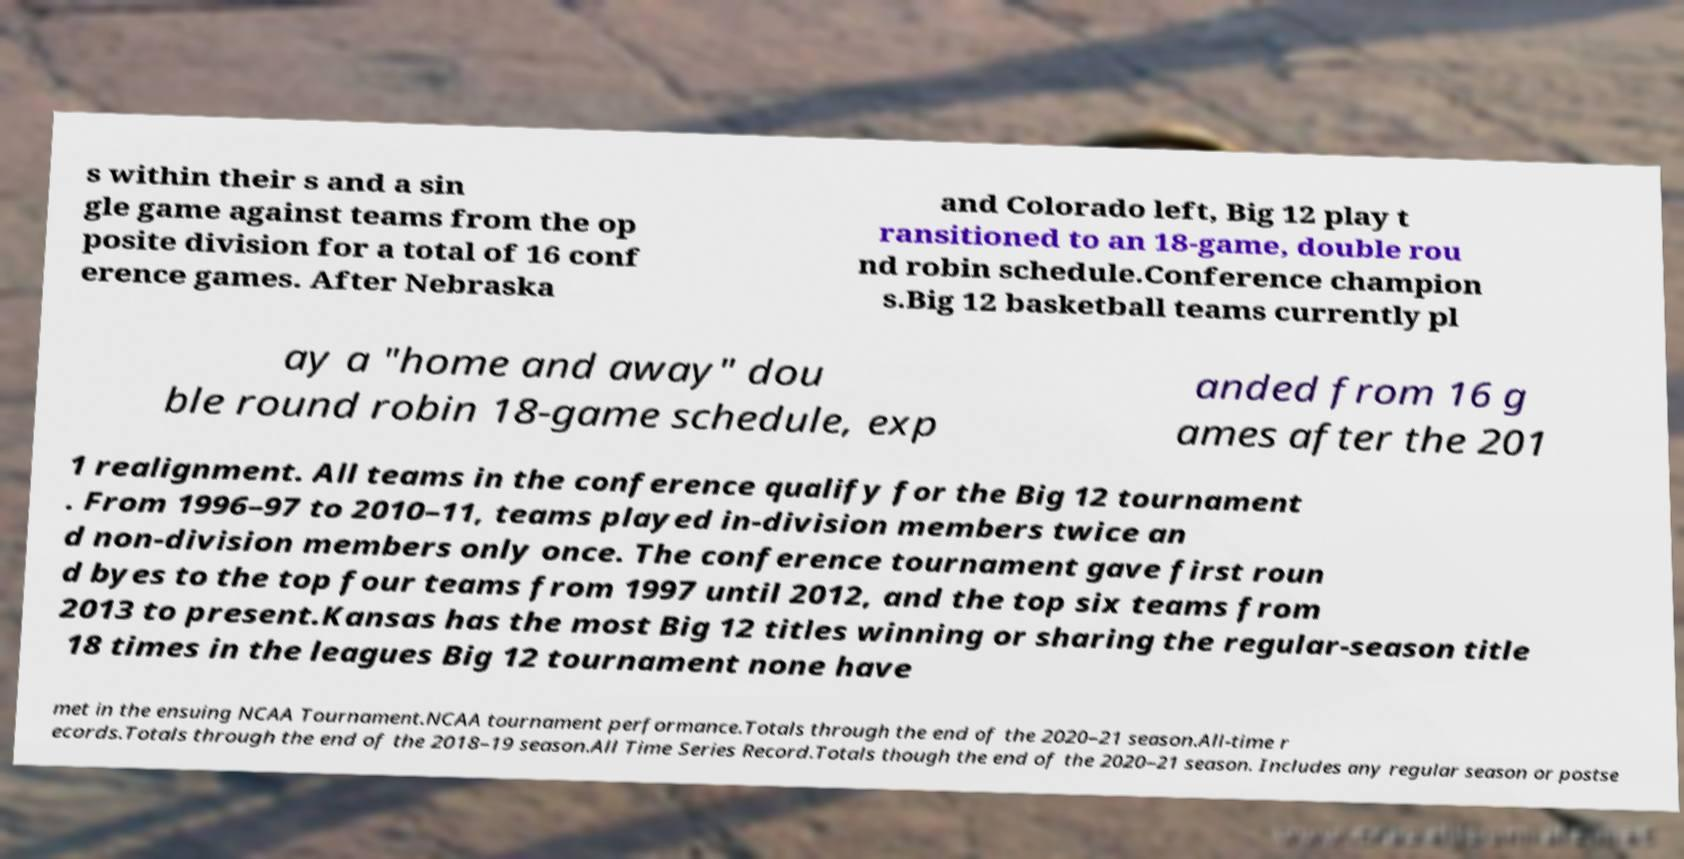What messages or text are displayed in this image? I need them in a readable, typed format. s within their s and a sin gle game against teams from the op posite division for a total of 16 conf erence games. After Nebraska and Colorado left, Big 12 play t ransitioned to an 18-game, double rou nd robin schedule.Conference champion s.Big 12 basketball teams currently pl ay a "home and away" dou ble round robin 18-game schedule, exp anded from 16 g ames after the 201 1 realignment. All teams in the conference qualify for the Big 12 tournament . From 1996–97 to 2010–11, teams played in-division members twice an d non-division members only once. The conference tournament gave first roun d byes to the top four teams from 1997 until 2012, and the top six teams from 2013 to present.Kansas has the most Big 12 titles winning or sharing the regular-season title 18 times in the leagues Big 12 tournament none have met in the ensuing NCAA Tournament.NCAA tournament performance.Totals through the end of the 2020–21 season.All-time r ecords.Totals through the end of the 2018–19 season.All Time Series Record.Totals though the end of the 2020–21 season. Includes any regular season or postse 